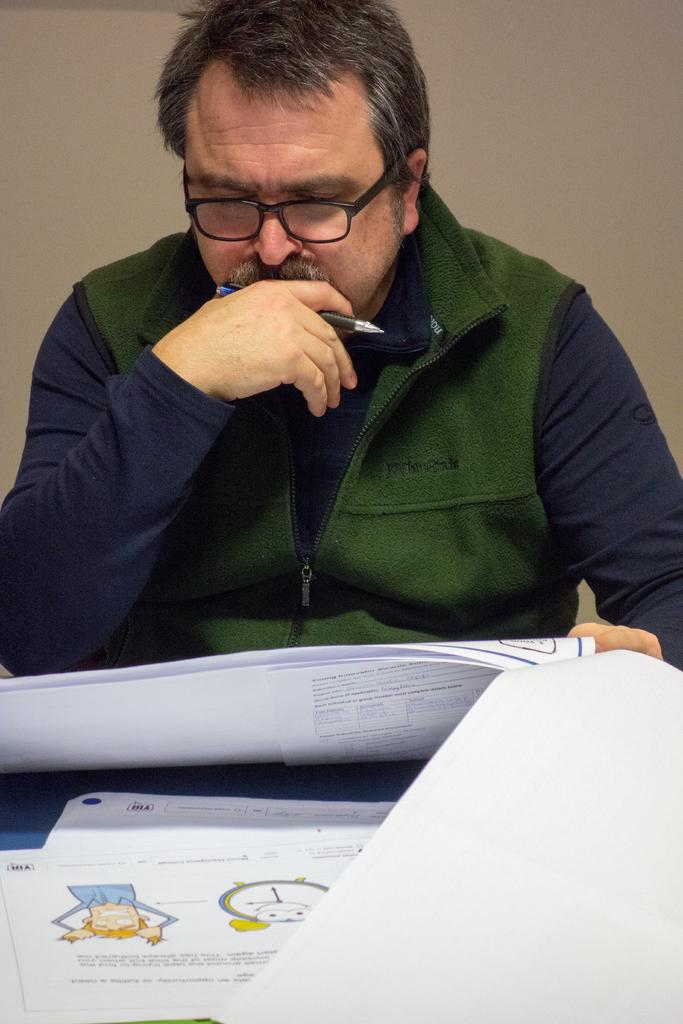What is the main subject of the image? There is a person in the image. What is the person holding in the image? The person is holding a pen. What can be seen on the table in the image? Papers are visible on the table. Are there any papers in front of the table? Yes, papers are present in front of the table. What might be behind the person in the image? The back side of the person might be a wall. What type of invention is the person working on in the image? There is no indication of an invention in the image; the person is simply holding a pen and there are papers on the table. Can you see a boat in the image? No, there is no boat present in the image. 